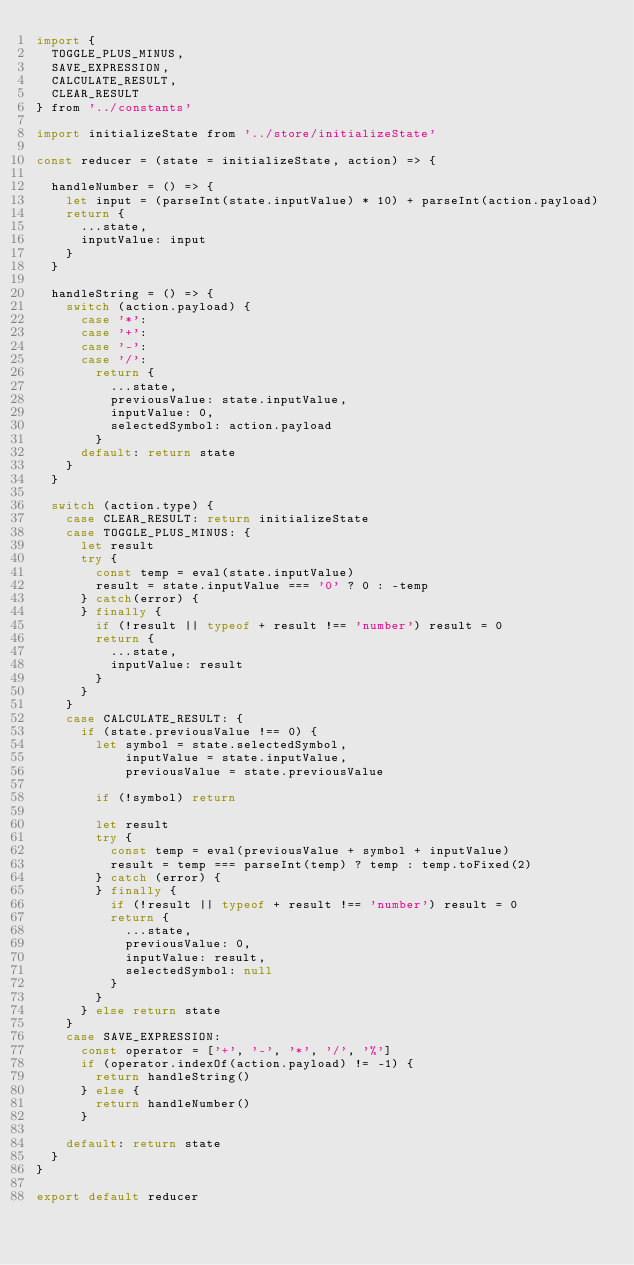<code> <loc_0><loc_0><loc_500><loc_500><_JavaScript_>import {
  TOGGLE_PLUS_MINUS,
  SAVE_EXPRESSION,
  CALCULATE_RESULT,
  CLEAR_RESULT
} from '../constants'

import initializeState from '../store/initializeState'

const reducer = (state = initializeState, action) => {

  handleNumber = () => {
    let input = (parseInt(state.inputValue) * 10) + parseInt(action.payload)
    return {
      ...state,
      inputValue: input
    }
  }

  handleString = () => {
    switch (action.payload) {
      case '*':
      case '+':
      case '-':
      case '/':
        return {
          ...state,
          previousValue: state.inputValue,
          inputValue: 0,
          selectedSymbol: action.payload
        }
      default: return state
    }
  }

  switch (action.type) {
    case CLEAR_RESULT: return initializeState
    case TOGGLE_PLUS_MINUS: {
      let result
      try {
        const temp = eval(state.inputValue)
        result = state.inputValue === '0' ? 0 : -temp
      } catch(error) {
      } finally {
        if (!result || typeof + result !== 'number') result = 0
        return {
          ...state,
          inputValue: result
        }
      }
    }
    case CALCULATE_RESULT: {
      if (state.previousValue !== 0) {
        let symbol = state.selectedSymbol,
            inputValue = state.inputValue,
            previousValue = state.previousValue

        if (!symbol) return

        let result
        try {
          const temp = eval(previousValue + symbol + inputValue)
          result = temp === parseInt(temp) ? temp : temp.toFixed(2)
        } catch (error) {
        } finally {
          if (!result || typeof + result !== 'number') result = 0
          return {
            ...state,
            previousValue: 0,
            inputValue: result,
            selectedSymbol: null
          }
        }
      } else return state
    }
    case SAVE_EXPRESSION:
      const operator = ['+', '-', '*', '/', '%']
      if (operator.indexOf(action.payload) != -1) {
        return handleString()
      } else {
        return handleNumber()
      }

    default: return state
  }
}

export default reducer
</code> 